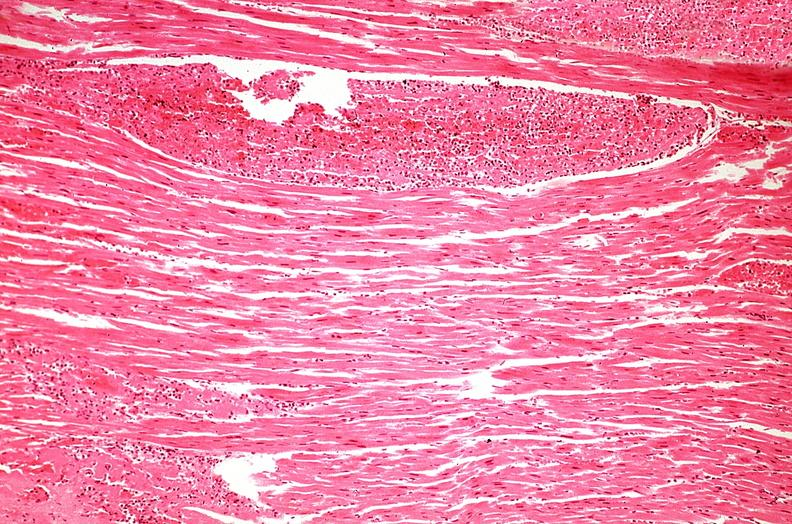s marfans syndrome present?
Answer the question using a single word or phrase. No 